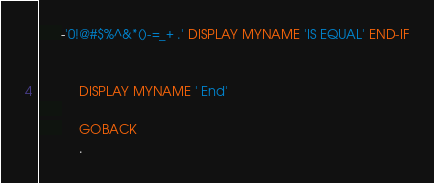Convert code to text. <code><loc_0><loc_0><loc_500><loc_500><_COBOL_>      -'0!@#$%^&*()-=_+ .' DISPLAY MYNAME 'IS EQUAL' END-IF
           

           DISPLAY MYNAME ' End'
           
           GOBACK
           .


</code> 